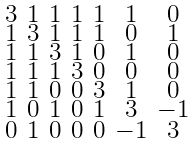Convert formula to latex. <formula><loc_0><loc_0><loc_500><loc_500>\begin{smallmatrix} 3 & 1 & 1 & 1 & 1 & 1 & 0 \\ 1 & 3 & 1 & 1 & 1 & 0 & 1 \\ 1 & 1 & 3 & 1 & 0 & 1 & 0 \\ 1 & 1 & 1 & 3 & 0 & 0 & 0 \\ 1 & 1 & 0 & 0 & 3 & 1 & 0 \\ 1 & 0 & 1 & 0 & 1 & 3 & - 1 \\ 0 & 1 & 0 & 0 & 0 & - 1 & 3 \end{smallmatrix}</formula> 